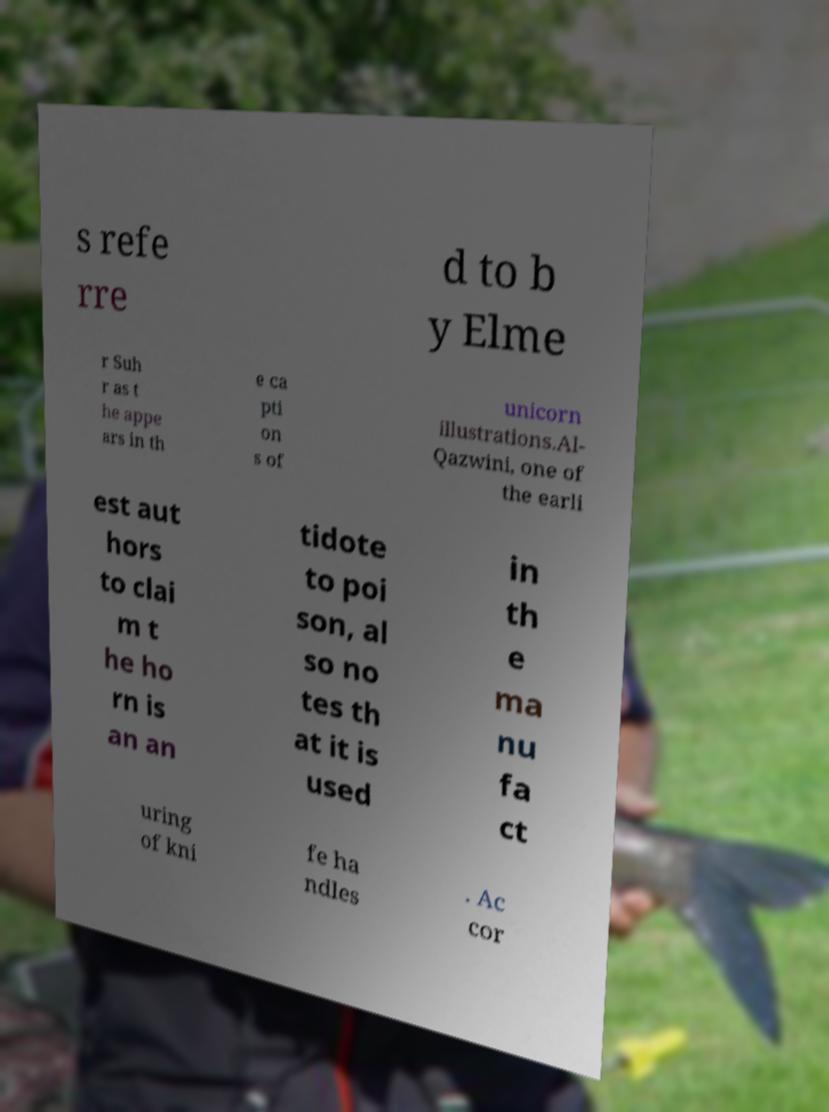Could you assist in decoding the text presented in this image and type it out clearly? s refe rre d to b y Elme r Suh r as t he appe ars in th e ca pti on s of unicorn illustrations.Al- Qazwini, one of the earli est aut hors to clai m t he ho rn is an an tidote to poi son, al so no tes th at it is used in th e ma nu fa ct uring of kni fe ha ndles . Ac cor 